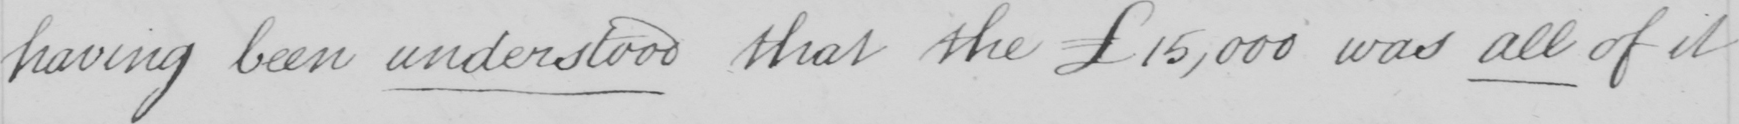What is written in this line of handwriting? having been understood that the £15,000 was all of it 